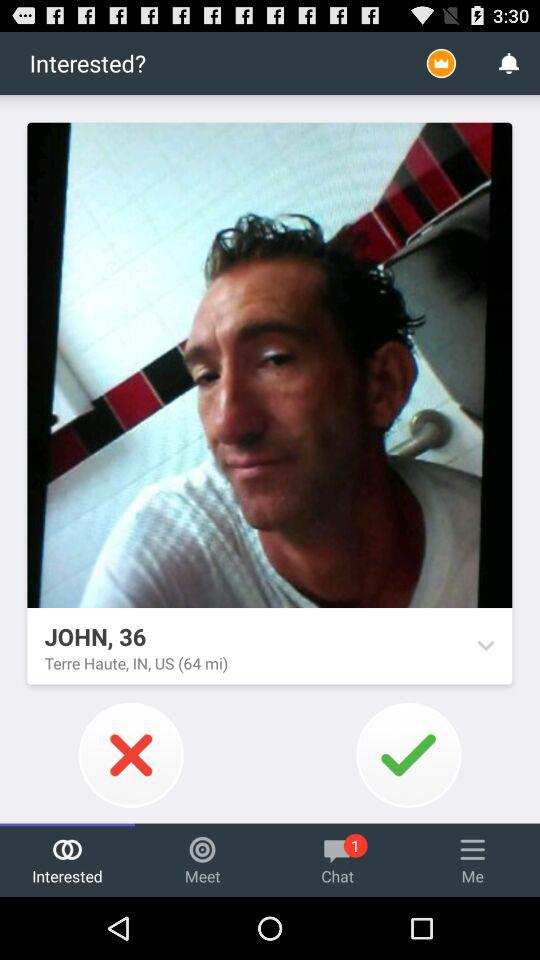What is the age of John? John is 36 years old. 